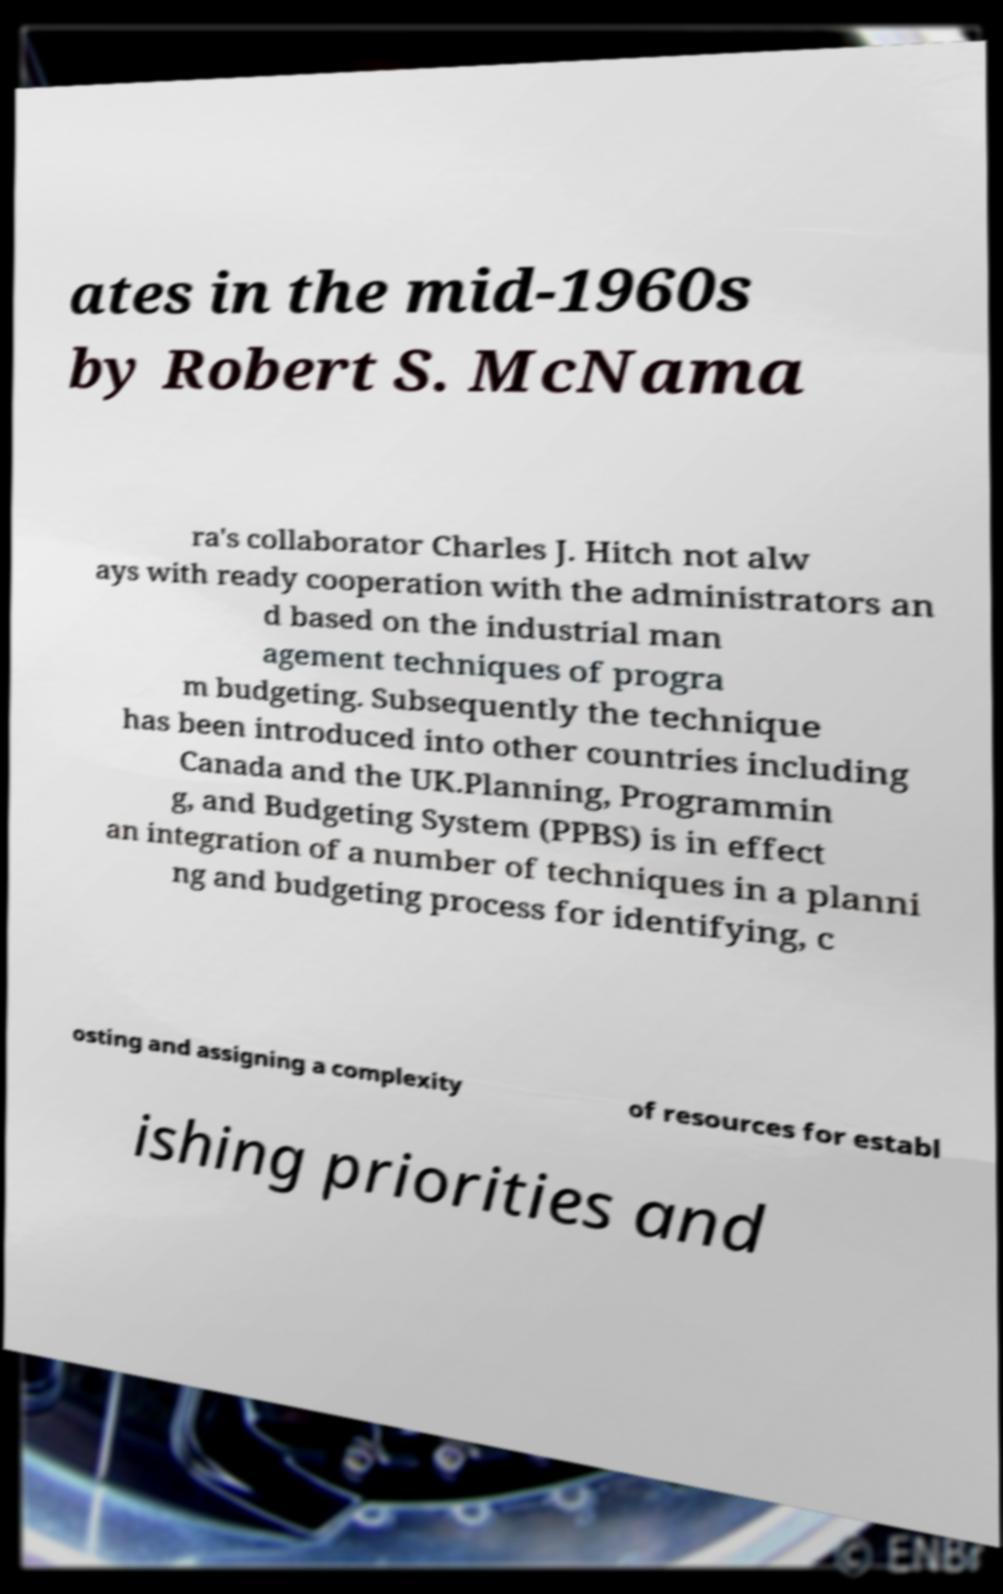Can you read and provide the text displayed in the image?This photo seems to have some interesting text. Can you extract and type it out for me? ates in the mid-1960s by Robert S. McNama ra's collaborator Charles J. Hitch not alw ays with ready cooperation with the administrators an d based on the industrial man agement techniques of progra m budgeting. Subsequently the technique has been introduced into other countries including Canada and the UK.Planning, Programmin g, and Budgeting System (PPBS) is in effect an integration of a number of techniques in a planni ng and budgeting process for identifying, c osting and assigning a complexity of resources for establ ishing priorities and 